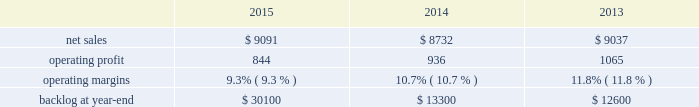$ 15 million for fire control programs due to increased deliveries ( primarily apache ) , partially offset by lower risk retirements ( primarily sniper ae ) .
Adjustments not related to volume , including net profit booking rate adjustments and other matters , were approximately $ 95 million lower for 2014 compared to 2013 .
Backlog backlog increased in 2015 compared to 2014 primarily due to higher orders on pac-3 , lantirn/sniper and certain tactical missile programs , partially offset by lower orders on thaad .
Backlog decreased in 2014 compared to 2013 primarily due to lower orders on thaad and fire control systems programs , partially offset by higher orders on certain tactical missile programs and pac-3 .
Trends we expect mfc 2019s net sales to be flat or experience a slight decline in 2016 as compared to 2015 .
Operating profit is expected to decrease by approximately 20 percent , driven by contract mix and fewer risk retirements in 2016 compared to 2015 .
Accordingly , operating profit margin is expected to decline from 2015 levels .
Mission systems and training as previously described , on november 6 , 2015 , we acquired sikorsky and aligned the sikorsky business under our mst business segment .
The results of the acquired sikorsky business have been included in our financial results from the november 6 , 2015 acquisition date through december 31 , 2015 .
As a result , our consolidated operating results and mst business segment operating results for the year ended december 31 , 2015 do not reflect a full year of sikorsky operations .
Our mst business segment provides design , manufacture , service and support for a variety of military and civil helicopters , ship and submarine mission and combat systems ; mission systems and sensors for rotary and fixed-wing aircraft ; sea and land-based missile defense systems ; radar systems ; the littoral combat ship ( lcs ) ; simulation and training services ; and unmanned systems and technologies .
In addition , mst supports the needs of customers in cybersecurity and delivers communication and command and control capabilities through complex mission solutions for defense applications .
Mst 2019s major programs include black hawk and seahawk helicopters , aegis combat system ( aegis ) , lcs , space fence , advanced hawkeye radar system , and tpq-53 radar system .
Mst 2019s operating results included the following ( in millions ) : .
2015 compared to 2014 mst 2019s net sales in 2015 increased $ 359 million , or 4% ( 4 % ) , compared to 2014 .
The increase was attributable to net sales of approximately $ 400 million from sikorsky , net of adjustments required to account for the acquisition of this business in the fourth quarter of 2015 ; and approximately $ 220 million for integrated warfare systems and sensors programs , primarily due to the ramp-up of recently awarded programs ( space fence ) .
These increases were partially offset by lower net sales of approximately $ 150 million for undersea systems programs due to decreased volume as a result of in-theater force reductions ( primarily persistent threat detection system ) ; and approximately $ 105 million for ship and aviation systems programs primarily due to decreased volume ( merlin capability sustainment program ) .
Mst 2019s operating profit in 2015 decreased $ 92 million , or 10% ( 10 % ) , compared to 2014 .
Operating profit decreased by approximately $ 75 million due to performance matters on an international program ; approximately $ 45 million for sikorsky due primarily to intangible amortization and adjustments required to account for the acquisition of this business in the fourth quarter of 2015 ; and approximately $ 15 million for integrated warfare systems and sensors programs , primarily due to investments made in connection with a recently awarded next generation radar technology program , partially offset by higher risk retirements ( including halifax class modernization ) .
These decreases were partially offset by approximately $ 20 million in increased operating profit for training and logistics services programs , primarily due to reserves recorded on certain programs in 2014 that were not repeated in 2015 .
Adjustments not related to volume , including net profit booking rate adjustments and other matters , were approximately $ 100 million lower in 2015 compared to 2014. .
What was the average operating profit for mst from 2013 to 2015? 
Computations: (((844 / 936) + 1065) / 3)
Answer: 355.30057. 